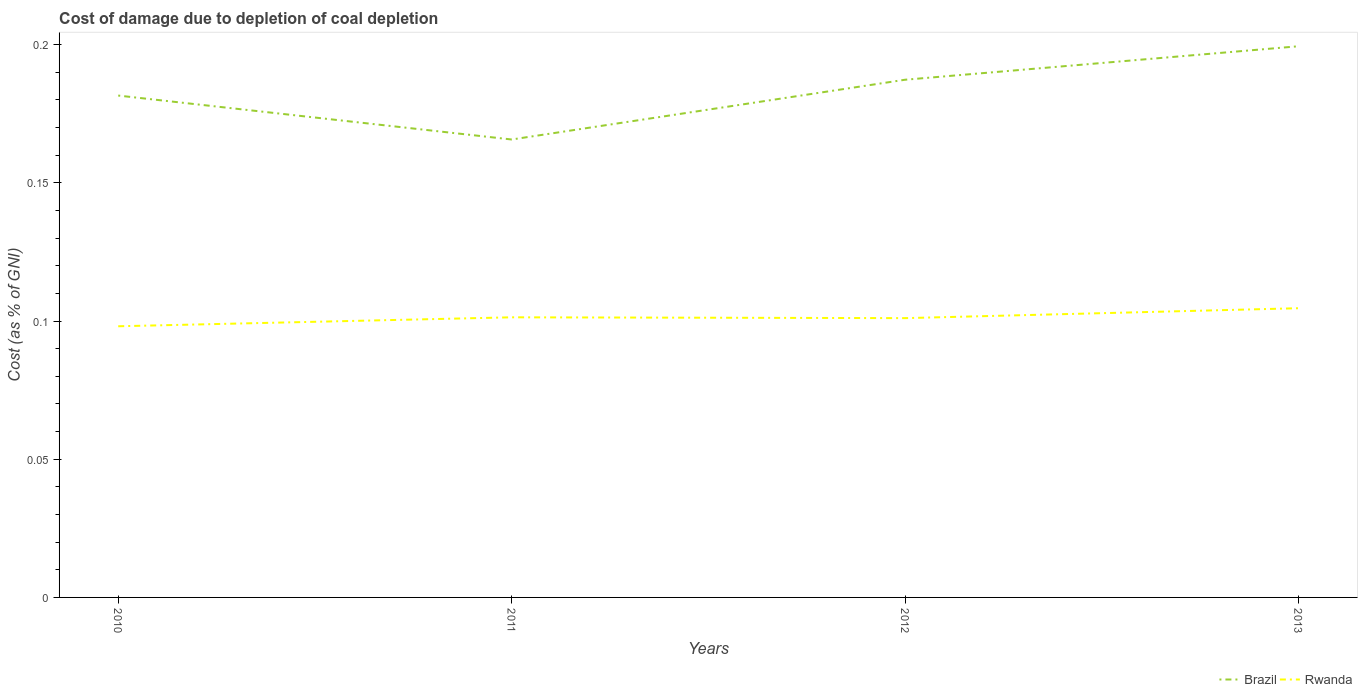Is the number of lines equal to the number of legend labels?
Your response must be concise. Yes. Across all years, what is the maximum cost of damage caused due to coal depletion in Rwanda?
Your answer should be compact. 0.1. What is the total cost of damage caused due to coal depletion in Brazil in the graph?
Ensure brevity in your answer.  -0.02. What is the difference between the highest and the second highest cost of damage caused due to coal depletion in Rwanda?
Your answer should be very brief. 0.01. What is the difference between the highest and the lowest cost of damage caused due to coal depletion in Rwanda?
Your response must be concise. 2. Does the graph contain any zero values?
Your response must be concise. No. Does the graph contain grids?
Your answer should be compact. No. Where does the legend appear in the graph?
Your answer should be very brief. Bottom right. How are the legend labels stacked?
Keep it short and to the point. Horizontal. What is the title of the graph?
Keep it short and to the point. Cost of damage due to depletion of coal depletion. What is the label or title of the Y-axis?
Offer a very short reply. Cost (as % of GNI). What is the Cost (as % of GNI) in Brazil in 2010?
Your answer should be compact. 0.18. What is the Cost (as % of GNI) in Rwanda in 2010?
Your response must be concise. 0.1. What is the Cost (as % of GNI) in Brazil in 2011?
Give a very brief answer. 0.17. What is the Cost (as % of GNI) in Rwanda in 2011?
Provide a short and direct response. 0.1. What is the Cost (as % of GNI) of Brazil in 2012?
Offer a terse response. 0.19. What is the Cost (as % of GNI) of Rwanda in 2012?
Ensure brevity in your answer.  0.1. What is the Cost (as % of GNI) in Brazil in 2013?
Offer a terse response. 0.2. What is the Cost (as % of GNI) in Rwanda in 2013?
Make the answer very short. 0.1. Across all years, what is the maximum Cost (as % of GNI) in Brazil?
Make the answer very short. 0.2. Across all years, what is the maximum Cost (as % of GNI) of Rwanda?
Offer a terse response. 0.1. Across all years, what is the minimum Cost (as % of GNI) of Brazil?
Make the answer very short. 0.17. Across all years, what is the minimum Cost (as % of GNI) of Rwanda?
Ensure brevity in your answer.  0.1. What is the total Cost (as % of GNI) of Brazil in the graph?
Provide a succinct answer. 0.73. What is the total Cost (as % of GNI) in Rwanda in the graph?
Make the answer very short. 0.41. What is the difference between the Cost (as % of GNI) in Brazil in 2010 and that in 2011?
Make the answer very short. 0.02. What is the difference between the Cost (as % of GNI) of Rwanda in 2010 and that in 2011?
Offer a terse response. -0. What is the difference between the Cost (as % of GNI) of Brazil in 2010 and that in 2012?
Offer a terse response. -0.01. What is the difference between the Cost (as % of GNI) of Rwanda in 2010 and that in 2012?
Your answer should be compact. -0. What is the difference between the Cost (as % of GNI) of Brazil in 2010 and that in 2013?
Provide a short and direct response. -0.02. What is the difference between the Cost (as % of GNI) of Rwanda in 2010 and that in 2013?
Your response must be concise. -0.01. What is the difference between the Cost (as % of GNI) of Brazil in 2011 and that in 2012?
Your answer should be very brief. -0.02. What is the difference between the Cost (as % of GNI) in Brazil in 2011 and that in 2013?
Offer a very short reply. -0.03. What is the difference between the Cost (as % of GNI) in Rwanda in 2011 and that in 2013?
Provide a short and direct response. -0. What is the difference between the Cost (as % of GNI) in Brazil in 2012 and that in 2013?
Provide a short and direct response. -0.01. What is the difference between the Cost (as % of GNI) of Rwanda in 2012 and that in 2013?
Your answer should be very brief. -0. What is the difference between the Cost (as % of GNI) of Brazil in 2010 and the Cost (as % of GNI) of Rwanda in 2011?
Provide a short and direct response. 0.08. What is the difference between the Cost (as % of GNI) in Brazil in 2010 and the Cost (as % of GNI) in Rwanda in 2012?
Give a very brief answer. 0.08. What is the difference between the Cost (as % of GNI) in Brazil in 2010 and the Cost (as % of GNI) in Rwanda in 2013?
Provide a short and direct response. 0.08. What is the difference between the Cost (as % of GNI) of Brazil in 2011 and the Cost (as % of GNI) of Rwanda in 2012?
Keep it short and to the point. 0.06. What is the difference between the Cost (as % of GNI) in Brazil in 2011 and the Cost (as % of GNI) in Rwanda in 2013?
Your answer should be very brief. 0.06. What is the difference between the Cost (as % of GNI) in Brazil in 2012 and the Cost (as % of GNI) in Rwanda in 2013?
Your answer should be compact. 0.08. What is the average Cost (as % of GNI) of Brazil per year?
Offer a terse response. 0.18. What is the average Cost (as % of GNI) in Rwanda per year?
Offer a very short reply. 0.1. In the year 2010, what is the difference between the Cost (as % of GNI) of Brazil and Cost (as % of GNI) of Rwanda?
Your answer should be compact. 0.08. In the year 2011, what is the difference between the Cost (as % of GNI) in Brazil and Cost (as % of GNI) in Rwanda?
Ensure brevity in your answer.  0.06. In the year 2012, what is the difference between the Cost (as % of GNI) of Brazil and Cost (as % of GNI) of Rwanda?
Offer a very short reply. 0.09. In the year 2013, what is the difference between the Cost (as % of GNI) in Brazil and Cost (as % of GNI) in Rwanda?
Offer a terse response. 0.09. What is the ratio of the Cost (as % of GNI) in Brazil in 2010 to that in 2011?
Offer a very short reply. 1.1. What is the ratio of the Cost (as % of GNI) in Brazil in 2010 to that in 2012?
Make the answer very short. 0.97. What is the ratio of the Cost (as % of GNI) of Rwanda in 2010 to that in 2012?
Your response must be concise. 0.97. What is the ratio of the Cost (as % of GNI) of Brazil in 2010 to that in 2013?
Make the answer very short. 0.91. What is the ratio of the Cost (as % of GNI) in Rwanda in 2010 to that in 2013?
Offer a very short reply. 0.94. What is the ratio of the Cost (as % of GNI) of Brazil in 2011 to that in 2012?
Provide a succinct answer. 0.88. What is the ratio of the Cost (as % of GNI) in Brazil in 2011 to that in 2013?
Provide a succinct answer. 0.83. What is the ratio of the Cost (as % of GNI) of Rwanda in 2011 to that in 2013?
Make the answer very short. 0.97. What is the ratio of the Cost (as % of GNI) of Brazil in 2012 to that in 2013?
Your answer should be very brief. 0.94. What is the ratio of the Cost (as % of GNI) of Rwanda in 2012 to that in 2013?
Ensure brevity in your answer.  0.97. What is the difference between the highest and the second highest Cost (as % of GNI) in Brazil?
Your response must be concise. 0.01. What is the difference between the highest and the second highest Cost (as % of GNI) in Rwanda?
Your answer should be very brief. 0. What is the difference between the highest and the lowest Cost (as % of GNI) of Brazil?
Make the answer very short. 0.03. What is the difference between the highest and the lowest Cost (as % of GNI) of Rwanda?
Your answer should be very brief. 0.01. 